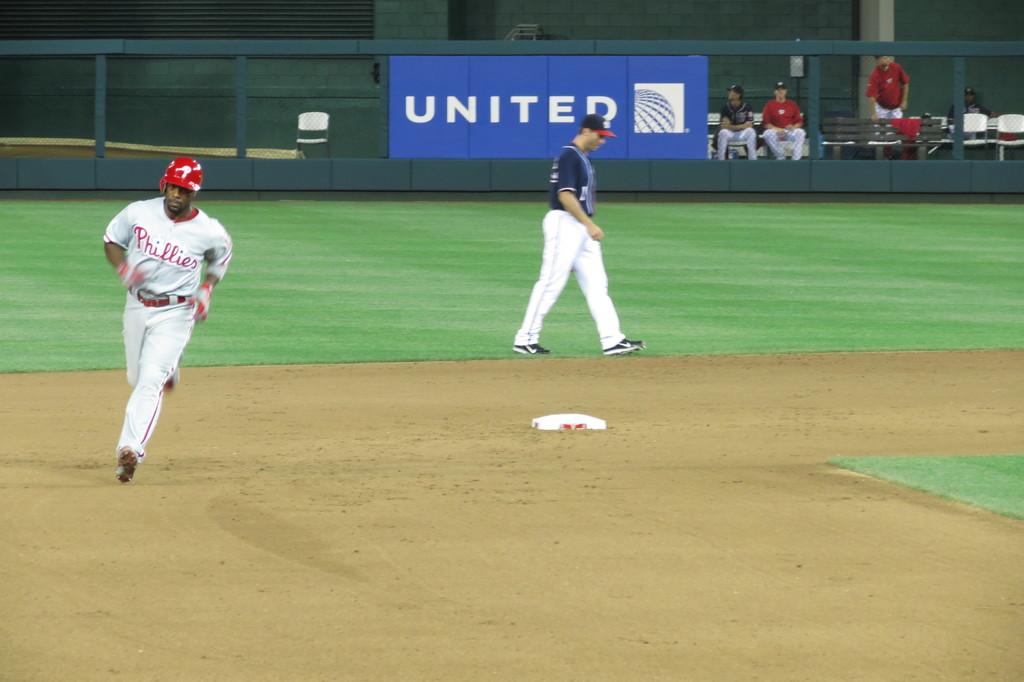What sponsor is advertised on the blue sign?
Keep it short and to the point. United. 